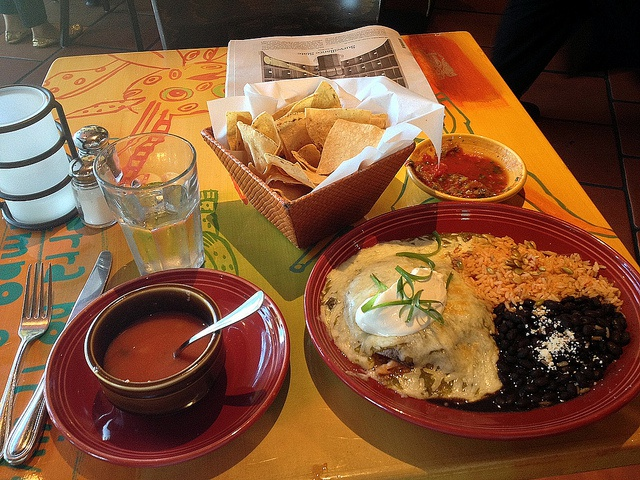Describe the objects in this image and their specific colors. I can see dining table in teal, olive, maroon, and orange tones, bowl in teal, black, maroon, brown, and gray tones, cup in teal, orange, tan, olive, and gray tones, bowl in teal, maroon, black, brown, and tan tones, and bowl in teal, maroon, brown, and orange tones in this image. 